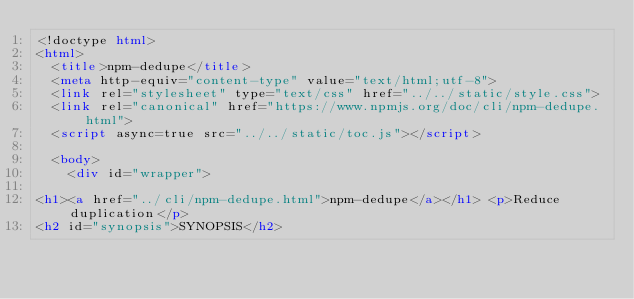Convert code to text. <code><loc_0><loc_0><loc_500><loc_500><_HTML_><!doctype html>
<html>
  <title>npm-dedupe</title>
  <meta http-equiv="content-type" value="text/html;utf-8">
  <link rel="stylesheet" type="text/css" href="../../static/style.css">
  <link rel="canonical" href="https://www.npmjs.org/doc/cli/npm-dedupe.html">
  <script async=true src="../../static/toc.js"></script>

  <body>
    <div id="wrapper">

<h1><a href="../cli/npm-dedupe.html">npm-dedupe</a></h1> <p>Reduce duplication</p>
<h2 id="synopsis">SYNOPSIS</h2></code> 